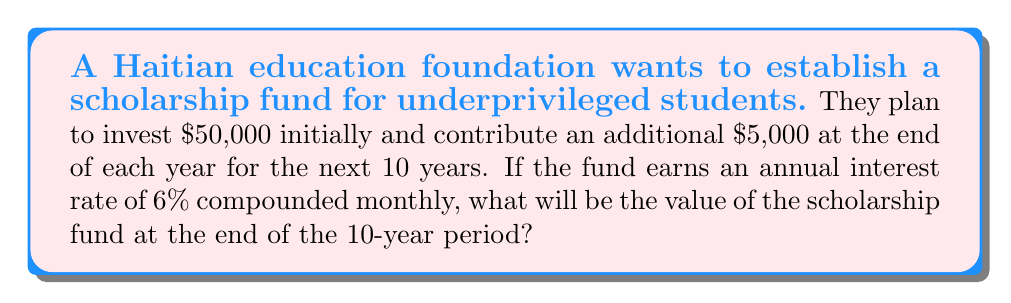Teach me how to tackle this problem. To solve this problem, we need to calculate two components:

1. The future value of the initial investment
2. The future value of the annual contributions

1. Future value of the initial investment:
We can use the compound interest formula:
$$A = P(1 + \frac{r}{n})^{nt}$$
Where:
$A$ = final amount
$P$ = principal (initial investment)
$r$ = annual interest rate
$n$ = number of times interest is compounded per year
$t$ = number of years

For our case:
$P = 50,000$
$r = 0.06$
$n = 12$ (compounded monthly)
$t = 10$

$$A_1 = 50,000(1 + \frac{0.06}{12})^{12 * 10} = 90,305.51$$

2. Future value of annual contributions:
For this, we can use the future value of an annuity formula:
$$A = PMT * \frac{(1 + \frac{r}{n})^{nt} - 1}{\frac{r}{n}}$$
Where:
$PMT$ = regular payment amount

For our case:
$PMT = 5,000$
$r = 0.06$
$n = 12$
$t = 10$

$$A_2 = 5,000 * \frac{(1 + \frac{0.06}{12})^{12 * 10} - 1}{\frac{0.06}{12}} = 66,651.83$$

The total future value of the scholarship fund is the sum of these two components:

$$\text{Total} = A_1 + A_2 = 90,305.51 + 66,651.83 = 156,957.34$$
Answer: $156,957.34 